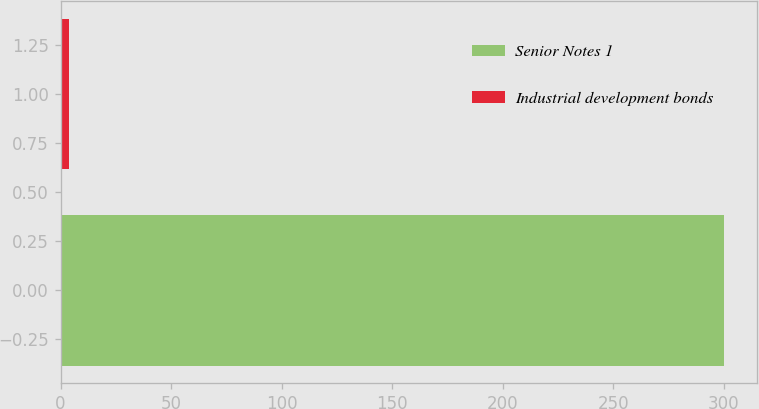Convert chart to OTSL. <chart><loc_0><loc_0><loc_500><loc_500><bar_chart><fcel>Senior Notes 1<fcel>Industrial development bonds<nl><fcel>300<fcel>3.8<nl></chart> 